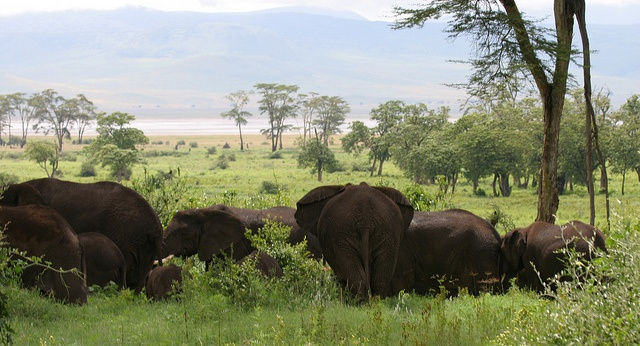Describe the objects in this image and their specific colors. I can see elephant in white, black, darkgreen, and olive tones, elephant in white, black, gray, and darkgreen tones, elephant in white, black, darkgreen, and olive tones, elephant in white, black, darkgreen, and gray tones, and elephant in white, black, olive, and gray tones in this image. 